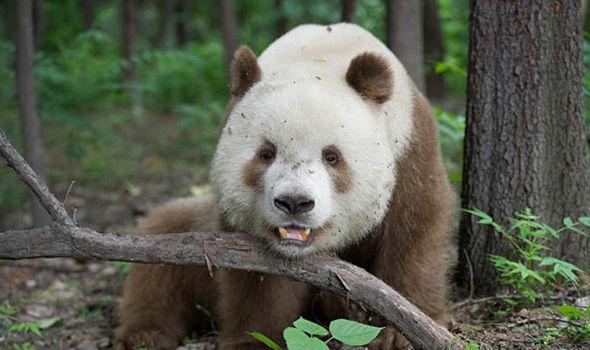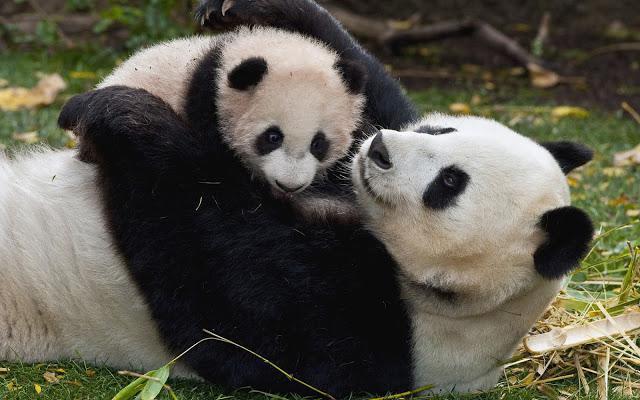The first image is the image on the left, the second image is the image on the right. Analyze the images presented: Is the assertion "An image shows two pandas in close contact." valid? Answer yes or no. Yes. The first image is the image on the left, the second image is the image on the right. For the images shown, is this caption "Two pandas are embracing each other." true? Answer yes or no. Yes. The first image is the image on the left, the second image is the image on the right. Considering the images on both sides, is "The panda in at least one of the images is holding a bamboo shoot." valid? Answer yes or no. No. The first image is the image on the left, the second image is the image on the right. Examine the images to the left and right. Is the description "An image shows a panda chewing on a green stalk." accurate? Answer yes or no. No. The first image is the image on the left, the second image is the image on the right. For the images displayed, is the sentence "In one of the images there are two pandas huddled together." factually correct? Answer yes or no. Yes. 